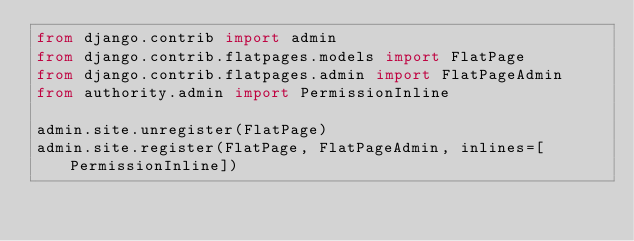Convert code to text. <code><loc_0><loc_0><loc_500><loc_500><_Python_>from django.contrib import admin
from django.contrib.flatpages.models import FlatPage
from django.contrib.flatpages.admin import FlatPageAdmin
from authority.admin import PermissionInline

admin.site.unregister(FlatPage)
admin.site.register(FlatPage, FlatPageAdmin, inlines=[PermissionInline])
</code> 